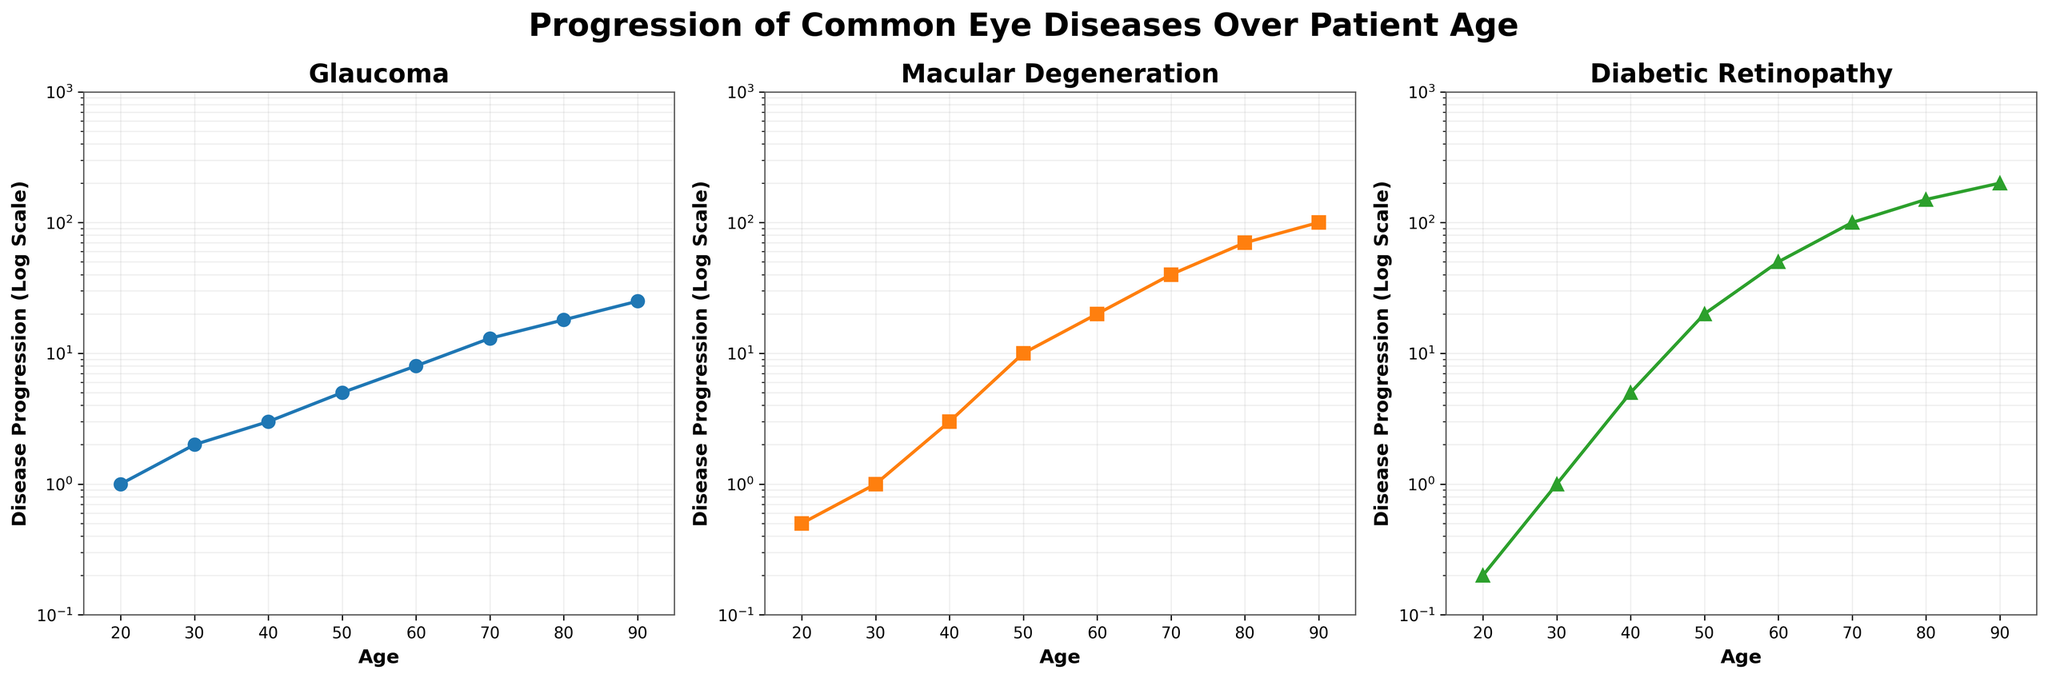What are the age ranges displayed on the x-axis? The x-axis for all subplots spans from 15 to 95 years old, as defined by the axis limits.
Answer: 15 to 95 What type of scale is used for the y-axis in the plots? All subplots use a logarithmic scale on the y-axis, allowing for a better visualization of data that spans several orders of magnitude.
Answer: Logarithmic scale Which disease has the steepest increase in progression between ages 50 and 70? By observing the slopes of the lines in the plots, "Diabetic Retinopathy" shows the steepest increase from approximately 20 at age 50 to 100 at age 70.
Answer: Diabetic Retinopathy At what age does glaucoma start to increase more rapidly? Glaucoma progression shows a noticeable increase starting around age 50, where the slope of the line becomes steeper.
Answer: Around age 50 How does the progression of macular degeneration at age 60 compare to that of diabetic retinopathy at the same age? At age 60, macular degeneration has a value of 20, whereas diabetic retinopathy has a higher value of 50.
Answer: Diabetic Retinopathy is higher How much does glaucoma progress from age 20 to age 90? Glaucoma progresses from a value of 1 at age 20 to 25 at age 90, a total increase of 24 units.
Answer: 24 units Which disease has the highest progression value at age 90? Diabetic retinopathy has the highest value at age 90, with a progression of 200.
Answer: Diabetic Retinopathy How do the progression trends compare between glaucoma and macular degeneration over the age range of the plots? Both diseases show increasing trends, but macular degeneration progresses more rapidly than glaucoma, particularly noticeable from age 50 onwards.
Answer: Macular Degeneration progresses more rapidly What is the value of macular degeneration at age 80, and how does it compare to diabetic retinopathy at the same age? At age 80, macular degeneration has a value of 70, while diabetic retinopathy has a higher value of 150.
Answer: Diabetic Retinopathy is higher at age 80 Which disease starts with the smallest value at age 20, and which has the highest value at age 90? At age 20, diabetic retinopathy starts with the smallest value of 0.2, and at age 90, diabetic retinopathy has the highest value of 200.
Answer: Diabetic Retinopathy starts smallest; Diabetic Retinopathy largest at age 90 